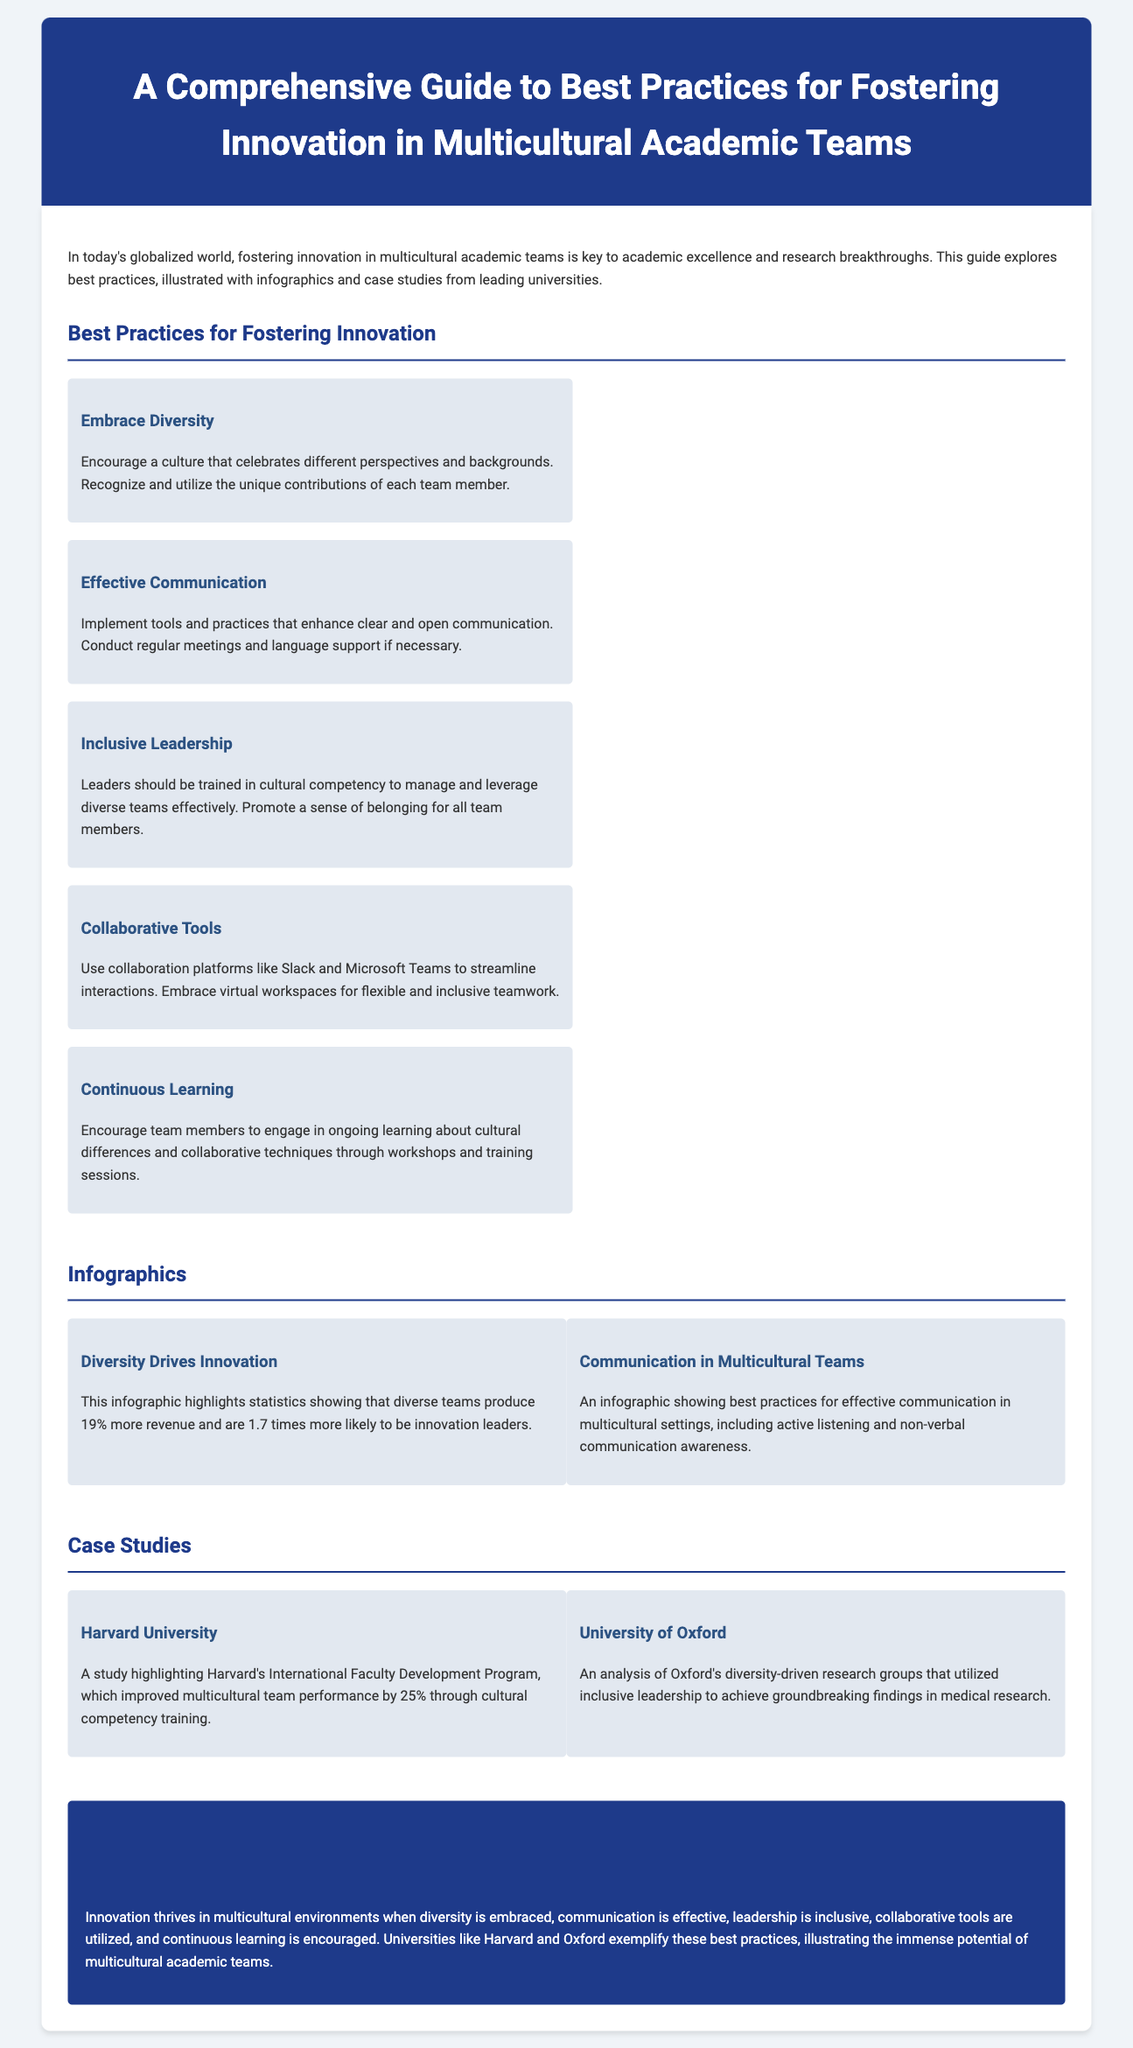What is the title of the guide? The title is mentioned at the top of the document in the header section.
Answer: A Comprehensive Guide to Best Practices for Fostering Innovation in Multicultural Academic Teams What university improved team performance by 25%? This information can be found in the case study section discussing Harvard University.
Answer: Harvard University How much more revenue do diverse teams produce? This statistic is highlighted in the infographic section about diversity and innovation.
Answer: 19% What is one of the best practices listed in the document? Best practices are outlined in a dedicated section; one example is listed in that section.
Answer: Embrace Diversity What does the infographic on communication in multicultural teams include? The infographic section provides a brief description of its content.
Answer: Active listening and non-verbal communication awareness What aspect of leadership is emphasized in the document? The content from the best practices section emphasizes an important leadership quality.
Answer: Inclusive Leadership Which university utilized diversity-driven research groups? This is mentioned in the case studies section when discussing Oxford University.
Answer: University of Oxford What drives innovation according to the guide? This is a conclusion drawn from the document, summarizing the key points.
Answer: Diversity 